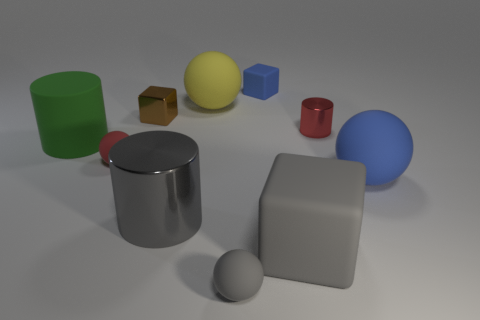How many metallic things are either green objects or small green cylinders?
Keep it short and to the point. 0. There is a rubber sphere that is the same color as the big cube; what is its size?
Give a very brief answer. Small. There is a small red thing to the left of the blue matte object that is behind the red matte ball; what is its material?
Your response must be concise. Rubber. How many things are brown metallic cubes or matte spheres that are right of the brown metal cube?
Keep it short and to the point. 4. What is the size of the other cylinder that is the same material as the small cylinder?
Keep it short and to the point. Large. What number of red objects are tiny matte things or spheres?
Your answer should be compact. 1. There is a matte object that is the same color as the tiny cylinder; what shape is it?
Your response must be concise. Sphere. Is there anything else that is made of the same material as the big block?
Provide a succinct answer. Yes. There is a small matte object behind the small brown metal block; does it have the same shape as the shiny object that is in front of the tiny red ball?
Offer a very short reply. No. What number of matte cubes are there?
Offer a terse response. 2. 